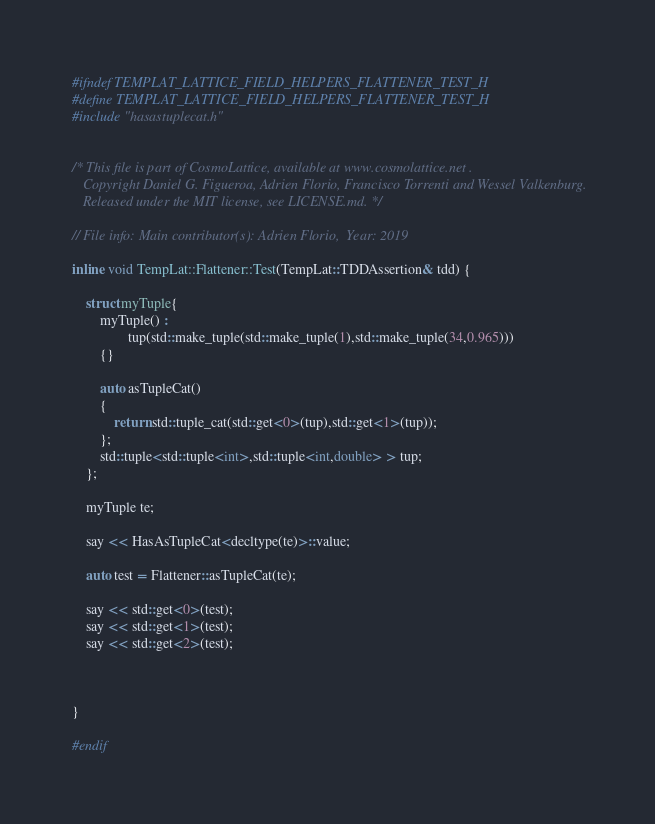<code> <loc_0><loc_0><loc_500><loc_500><_C_>#ifndef TEMPLAT_LATTICE_FIELD_HELPERS_FLATTENER_TEST_H
#define TEMPLAT_LATTICE_FIELD_HELPERS_FLATTENER_TEST_H
#include "hasastuplecat.h"

 
/* This file is part of CosmoLattice, available at www.cosmolattice.net .
   Copyright Daniel G. Figueroa, Adrien Florio, Francisco Torrenti and Wessel Valkenburg.
   Released under the MIT license, see LICENSE.md. */ 
   
// File info: Main contributor(s): Adrien Florio,  Year: 2019

inline void TempLat::Flattener::Test(TempLat::TDDAssertion& tdd) {

    struct myTuple{
        myTuple() :
                tup(std::make_tuple(std::make_tuple(1),std::make_tuple(34,0.965)))
        {}

        auto asTupleCat()
        {
            return std::tuple_cat(std::get<0>(tup),std::get<1>(tup));
        };
        std::tuple<std::tuple<int>,std::tuple<int,double> > tup;
    };

    myTuple te;

    say << HasAsTupleCat<decltype(te)>::value;

    auto test = Flattener::asTupleCat(te);

    say << std::get<0>(test);
    say << std::get<1>(test);
    say << std::get<2>(test);



}

#endif
</code> 